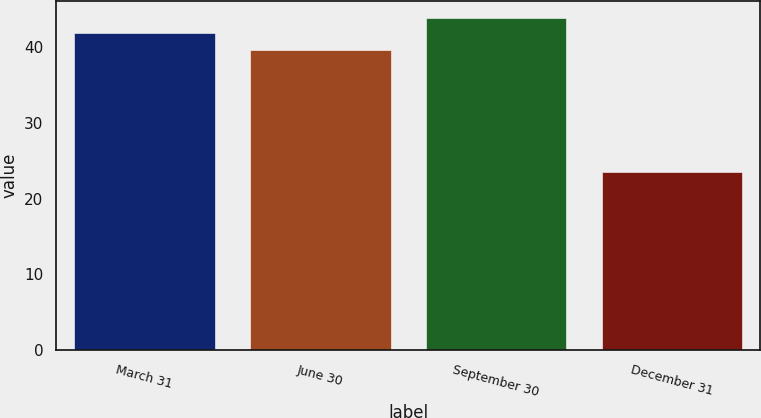Convert chart. <chart><loc_0><loc_0><loc_500><loc_500><bar_chart><fcel>March 31<fcel>June 30<fcel>September 30<fcel>December 31<nl><fcel>41.96<fcel>39.68<fcel>43.9<fcel>23.49<nl></chart> 